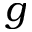<formula> <loc_0><loc_0><loc_500><loc_500>g</formula> 